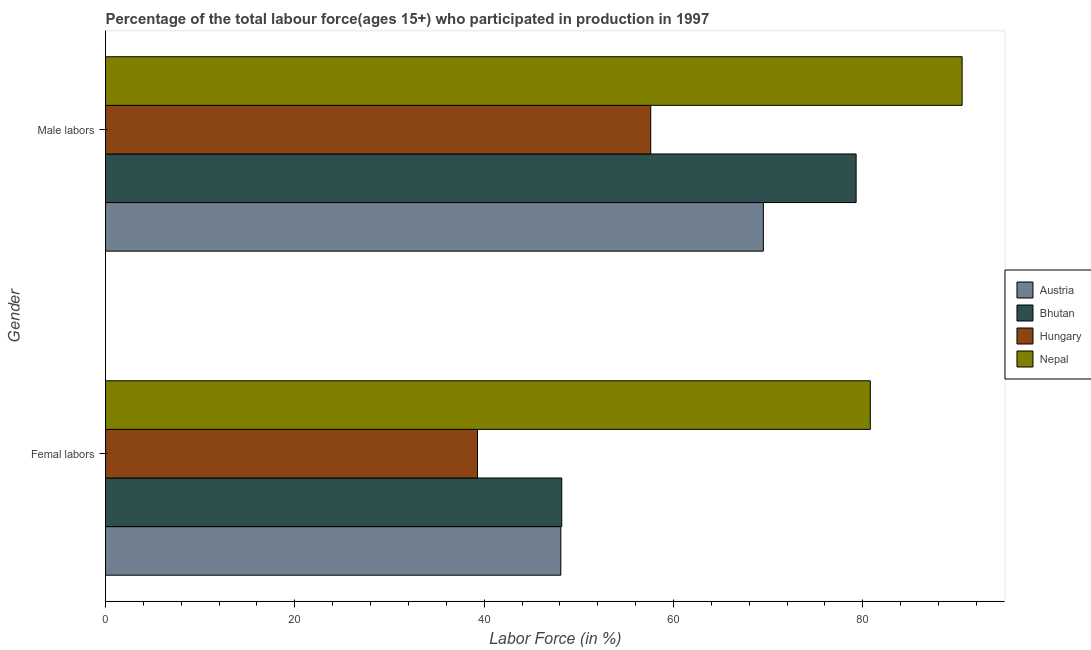Are the number of bars per tick equal to the number of legend labels?
Offer a terse response. Yes. How many bars are there on the 2nd tick from the top?
Your response must be concise. 4. How many bars are there on the 1st tick from the bottom?
Your answer should be compact. 4. What is the label of the 1st group of bars from the top?
Your response must be concise. Male labors. What is the percentage of female labor force in Austria?
Your answer should be compact. 48.1. Across all countries, what is the maximum percentage of female labor force?
Offer a very short reply. 80.8. Across all countries, what is the minimum percentage of male labour force?
Your answer should be very brief. 57.6. In which country was the percentage of female labor force maximum?
Give a very brief answer. Nepal. In which country was the percentage of female labor force minimum?
Ensure brevity in your answer.  Hungary. What is the total percentage of male labour force in the graph?
Provide a succinct answer. 296.9. What is the difference between the percentage of female labor force in Austria and that in Bhutan?
Provide a short and direct response. -0.1. What is the difference between the percentage of female labor force in Austria and the percentage of male labour force in Bhutan?
Make the answer very short. -31.2. What is the average percentage of male labour force per country?
Offer a very short reply. 74.23. What is the difference between the percentage of male labour force and percentage of female labor force in Bhutan?
Give a very brief answer. 31.1. In how many countries, is the percentage of male labour force greater than 52 %?
Offer a terse response. 4. What is the ratio of the percentage of female labor force in Nepal to that in Hungary?
Offer a terse response. 2.06. Is the percentage of male labour force in Hungary less than that in Austria?
Provide a short and direct response. Yes. In how many countries, is the percentage of male labour force greater than the average percentage of male labour force taken over all countries?
Your response must be concise. 2. What does the 2nd bar from the bottom in Femal labors represents?
Offer a terse response. Bhutan. Are all the bars in the graph horizontal?
Offer a very short reply. Yes. How many countries are there in the graph?
Offer a very short reply. 4. What is the difference between two consecutive major ticks on the X-axis?
Provide a short and direct response. 20. Does the graph contain grids?
Your answer should be compact. No. What is the title of the graph?
Keep it short and to the point. Percentage of the total labour force(ages 15+) who participated in production in 1997. What is the label or title of the X-axis?
Offer a terse response. Labor Force (in %). What is the Labor Force (in %) in Austria in Femal labors?
Make the answer very short. 48.1. What is the Labor Force (in %) of Bhutan in Femal labors?
Offer a very short reply. 48.2. What is the Labor Force (in %) in Hungary in Femal labors?
Provide a short and direct response. 39.3. What is the Labor Force (in %) in Nepal in Femal labors?
Ensure brevity in your answer.  80.8. What is the Labor Force (in %) in Austria in Male labors?
Your answer should be compact. 69.5. What is the Labor Force (in %) of Bhutan in Male labors?
Give a very brief answer. 79.3. What is the Labor Force (in %) in Hungary in Male labors?
Provide a short and direct response. 57.6. What is the Labor Force (in %) of Nepal in Male labors?
Provide a short and direct response. 90.5. Across all Gender, what is the maximum Labor Force (in %) in Austria?
Your response must be concise. 69.5. Across all Gender, what is the maximum Labor Force (in %) of Bhutan?
Your answer should be compact. 79.3. Across all Gender, what is the maximum Labor Force (in %) in Hungary?
Give a very brief answer. 57.6. Across all Gender, what is the maximum Labor Force (in %) in Nepal?
Make the answer very short. 90.5. Across all Gender, what is the minimum Labor Force (in %) of Austria?
Make the answer very short. 48.1. Across all Gender, what is the minimum Labor Force (in %) in Bhutan?
Your response must be concise. 48.2. Across all Gender, what is the minimum Labor Force (in %) in Hungary?
Ensure brevity in your answer.  39.3. Across all Gender, what is the minimum Labor Force (in %) of Nepal?
Provide a succinct answer. 80.8. What is the total Labor Force (in %) of Austria in the graph?
Your answer should be very brief. 117.6. What is the total Labor Force (in %) in Bhutan in the graph?
Provide a succinct answer. 127.5. What is the total Labor Force (in %) in Hungary in the graph?
Ensure brevity in your answer.  96.9. What is the total Labor Force (in %) in Nepal in the graph?
Your response must be concise. 171.3. What is the difference between the Labor Force (in %) in Austria in Femal labors and that in Male labors?
Make the answer very short. -21.4. What is the difference between the Labor Force (in %) in Bhutan in Femal labors and that in Male labors?
Provide a succinct answer. -31.1. What is the difference between the Labor Force (in %) in Hungary in Femal labors and that in Male labors?
Keep it short and to the point. -18.3. What is the difference between the Labor Force (in %) of Austria in Femal labors and the Labor Force (in %) of Bhutan in Male labors?
Offer a terse response. -31.2. What is the difference between the Labor Force (in %) of Austria in Femal labors and the Labor Force (in %) of Nepal in Male labors?
Your answer should be compact. -42.4. What is the difference between the Labor Force (in %) in Bhutan in Femal labors and the Labor Force (in %) in Nepal in Male labors?
Keep it short and to the point. -42.3. What is the difference between the Labor Force (in %) of Hungary in Femal labors and the Labor Force (in %) of Nepal in Male labors?
Keep it short and to the point. -51.2. What is the average Labor Force (in %) in Austria per Gender?
Make the answer very short. 58.8. What is the average Labor Force (in %) in Bhutan per Gender?
Provide a short and direct response. 63.75. What is the average Labor Force (in %) of Hungary per Gender?
Ensure brevity in your answer.  48.45. What is the average Labor Force (in %) of Nepal per Gender?
Make the answer very short. 85.65. What is the difference between the Labor Force (in %) of Austria and Labor Force (in %) of Bhutan in Femal labors?
Provide a short and direct response. -0.1. What is the difference between the Labor Force (in %) in Austria and Labor Force (in %) in Hungary in Femal labors?
Offer a terse response. 8.8. What is the difference between the Labor Force (in %) in Austria and Labor Force (in %) in Nepal in Femal labors?
Offer a terse response. -32.7. What is the difference between the Labor Force (in %) of Bhutan and Labor Force (in %) of Nepal in Femal labors?
Make the answer very short. -32.6. What is the difference between the Labor Force (in %) of Hungary and Labor Force (in %) of Nepal in Femal labors?
Your answer should be very brief. -41.5. What is the difference between the Labor Force (in %) of Austria and Labor Force (in %) of Bhutan in Male labors?
Your answer should be very brief. -9.8. What is the difference between the Labor Force (in %) of Austria and Labor Force (in %) of Hungary in Male labors?
Your response must be concise. 11.9. What is the difference between the Labor Force (in %) of Bhutan and Labor Force (in %) of Hungary in Male labors?
Provide a succinct answer. 21.7. What is the difference between the Labor Force (in %) in Hungary and Labor Force (in %) in Nepal in Male labors?
Ensure brevity in your answer.  -32.9. What is the ratio of the Labor Force (in %) of Austria in Femal labors to that in Male labors?
Your response must be concise. 0.69. What is the ratio of the Labor Force (in %) of Bhutan in Femal labors to that in Male labors?
Your response must be concise. 0.61. What is the ratio of the Labor Force (in %) in Hungary in Femal labors to that in Male labors?
Keep it short and to the point. 0.68. What is the ratio of the Labor Force (in %) of Nepal in Femal labors to that in Male labors?
Provide a short and direct response. 0.89. What is the difference between the highest and the second highest Labor Force (in %) in Austria?
Ensure brevity in your answer.  21.4. What is the difference between the highest and the second highest Labor Force (in %) of Bhutan?
Provide a short and direct response. 31.1. What is the difference between the highest and the second highest Labor Force (in %) in Hungary?
Your response must be concise. 18.3. What is the difference between the highest and the second highest Labor Force (in %) in Nepal?
Your answer should be compact. 9.7. What is the difference between the highest and the lowest Labor Force (in %) in Austria?
Your answer should be compact. 21.4. What is the difference between the highest and the lowest Labor Force (in %) of Bhutan?
Make the answer very short. 31.1. What is the difference between the highest and the lowest Labor Force (in %) in Hungary?
Ensure brevity in your answer.  18.3. 